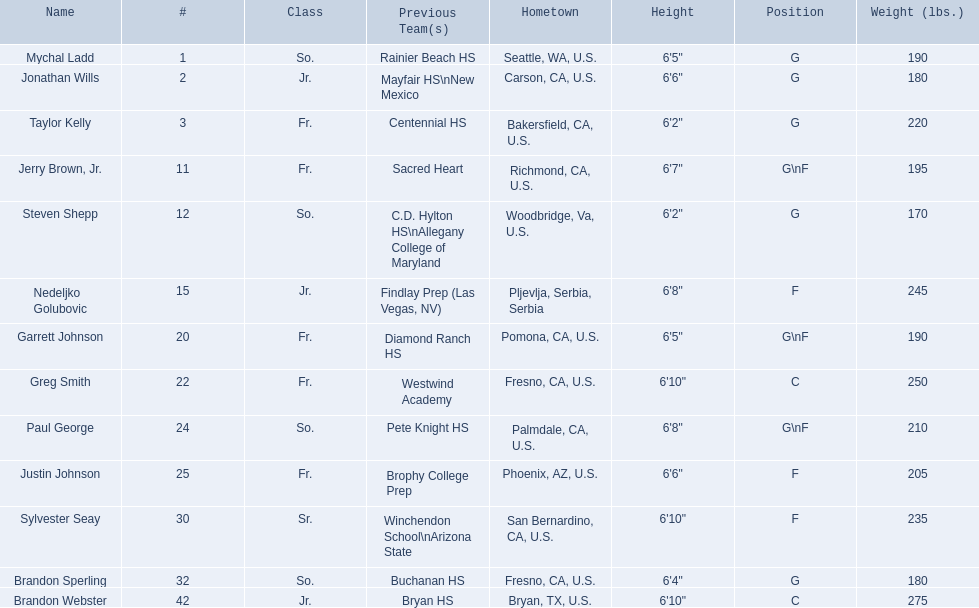Which players are forwards? Nedeljko Golubovic, Paul George, Justin Johnson, Sylvester Seay. What are the heights of these players? Nedeljko Golubovic, 6'8", Paul George, 6'8", Justin Johnson, 6'6", Sylvester Seay, 6'10". Of these players, who is the shortest? Justin Johnson. 